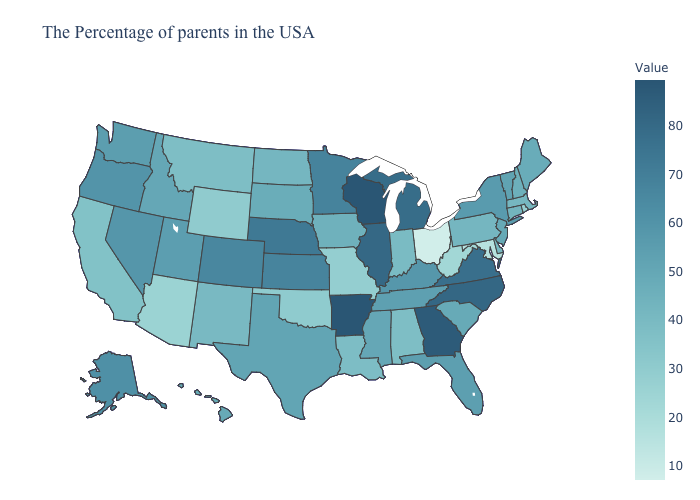Does Mississippi have the highest value in the South?
Give a very brief answer. No. Which states have the lowest value in the USA?
Keep it brief. Ohio. Does Colorado have the highest value in the West?
Write a very short answer. Yes. Which states have the lowest value in the USA?
Answer briefly. Ohio. Does Vermont have the highest value in the Northeast?
Give a very brief answer. No. 